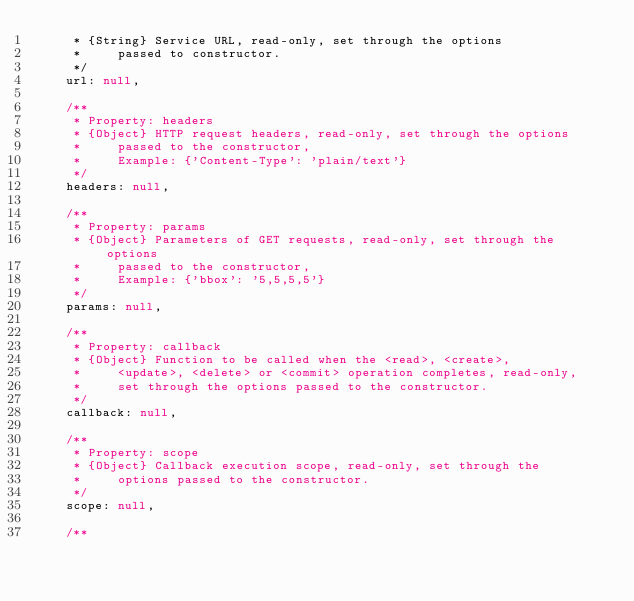Convert code to text. <code><loc_0><loc_0><loc_500><loc_500><_JavaScript_>     * {String} Service URL, read-only, set through the options
     *     passed to constructor.
     */
    url: null,

    /**
     * Property: headers
     * {Object} HTTP request headers, read-only, set through the options
     *     passed to the constructor,
     *     Example: {'Content-Type': 'plain/text'}
     */
    headers: null,

    /**
     * Property: params
     * {Object} Parameters of GET requests, read-only, set through the options
     *     passed to the constructor,
     *     Example: {'bbox': '5,5,5,5'}
     */
    params: null,
    
    /**
     * Property: callback
     * {Object} Function to be called when the <read>, <create>,
     *     <update>, <delete> or <commit> operation completes, read-only,
     *     set through the options passed to the constructor.
     */
    callback: null,

    /**
     * Property: scope
     * {Object} Callback execution scope, read-only, set through the
     *     options passed to the constructor.
     */
    scope: null,

    /**</code> 